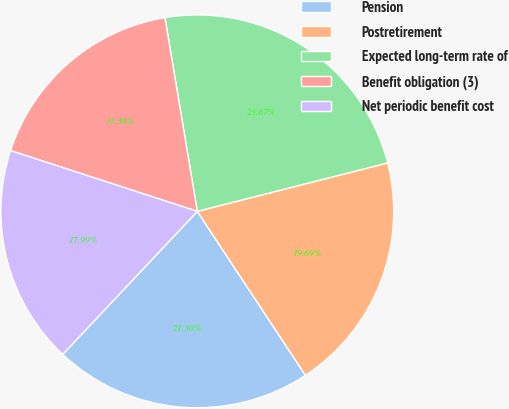Convert chart. <chart><loc_0><loc_0><loc_500><loc_500><pie_chart><fcel>Pension<fcel>Postretirement<fcel>Expected long-term rate of<fcel>Benefit obligation (3)<fcel>Net periodic benefit cost<nl><fcel>21.3%<fcel>19.69%<fcel>23.67%<fcel>17.36%<fcel>17.99%<nl></chart> 